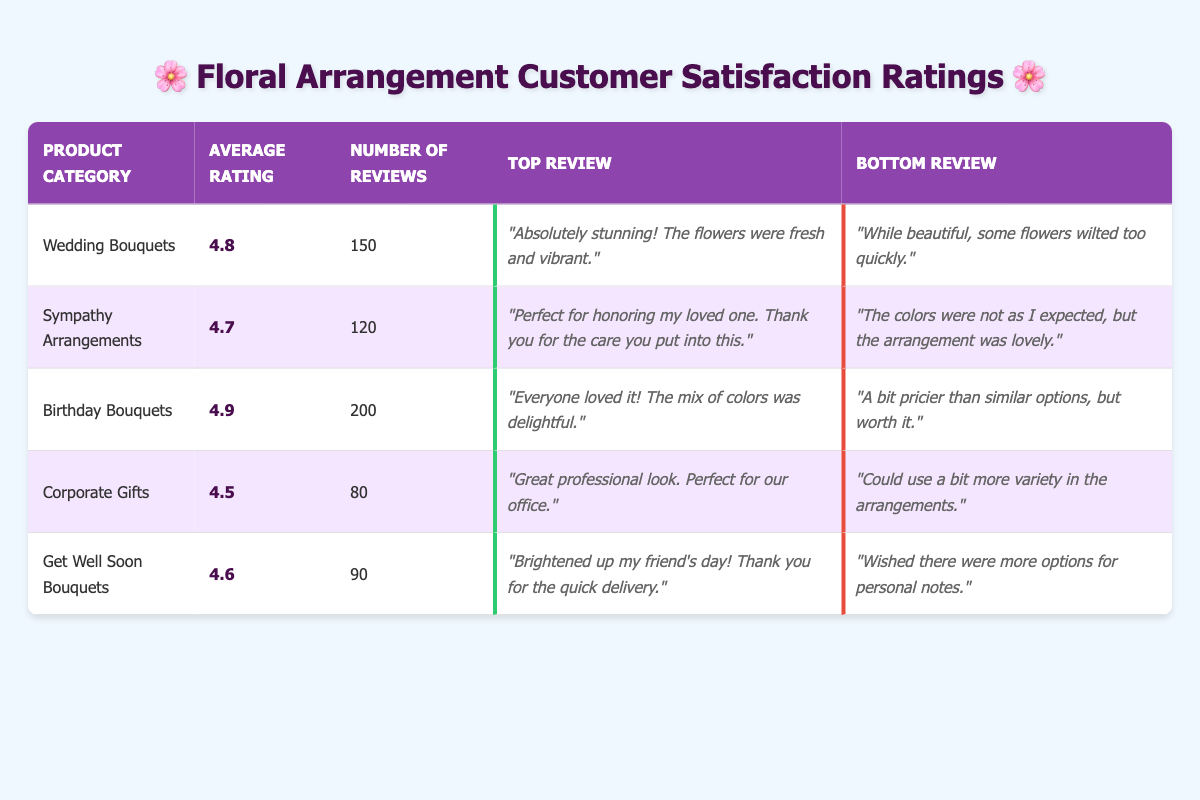What is the product category with the highest average rating? The average ratings for each product category are listed in the table. Checking the values, "Birthday Bouquets" has the highest average rating of 4.9.
Answer: Birthday Bouquets How many reviews were submitted for sympathy arrangements? The number of reviews for "Sympathy Arrangements" is directly stated in the table as 120.
Answer: 120 Is the average rating for Corporate Gifts above 4.5? The average rating for "Corporate Gifts" is 4.5, which means that it is not above 4.5, it is precisely 4.5.
Answer: No What is the average of the average ratings for all product categories? To find the average of the average ratings, sum the ratings (4.8 + 4.7 + 4.9 + 4.5 + 4.6 = 24.5) and divide by the number of categories (5). Thus, the average is 24.5 / 5 = 4.9.
Answer: 4.9 Which product category has the lowest number of reviews? By comparing the number of reviews across product categories, "Corporate Gifts" has the lowest number of reviews at 80.
Answer: Corporate Gifts Are Get Well Soon Bouquets rated higher than Sympathy Arrangements? Comparing the average ratings, "Get Well Soon Bouquets" has a rating of 4.6, while "Sympathy Arrangements" has a rating of 4.7. Thus, Get Well Soon Bouquets is not rated higher.
Answer: No What is the difference in average ratings between Birthday Bouquets and Wedding Bouquets? The average rating for "Birthday Bouquets" is 4.9, and the average for "Wedding Bouquets" is 4.8. The difference is calculated as 4.9 - 4.8 = 0.1.
Answer: 0.1 List the top review for Corporate Gifts. The top review for "Corporate Gifts" is clearly stated in the table as: "Great professional look. Perfect for our office."
Answer: Great professional look. Perfect for our office What is the sum of the number of reviews for all product categories? To find the sum, add the reviews for each category: 150 (Wedding Bouquets) + 120 (Sympathy Arrangements) + 200 (Birthday Bouquets) + 80 (Corporate Gifts) + 90 (Get Well Soon Bouquets) = 640.
Answer: 640 